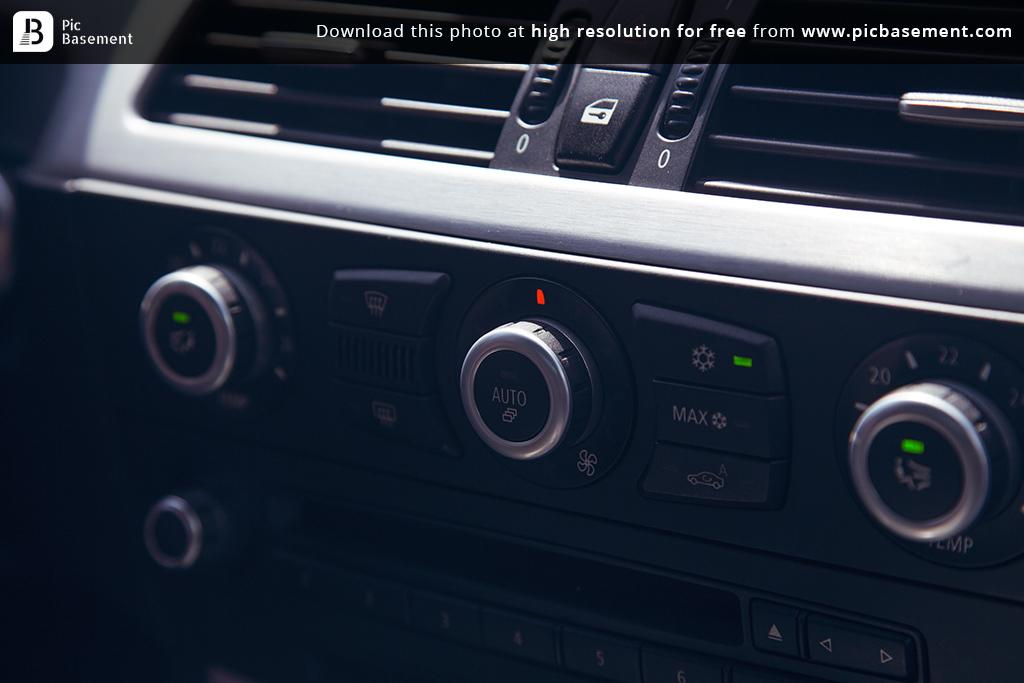What type of setting is depicted in the image? The image shows the interior part of a car. What objects can be seen inside the car? There are two AAC blocks and a few buttons visible in the image. How many horses are visible in the image? There are no horses present in the image; it shows the interior part of a car. What type of road can be seen through the car's window in the image? There is no window visible in the image, and therefore no road can be seen. 